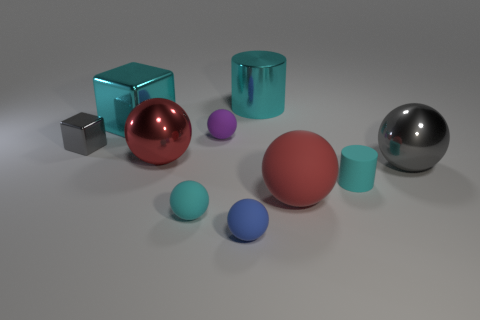Subtract all rubber balls. How many balls are left? 2 Subtract all cyan blocks. How many blocks are left? 1 Subtract all cylinders. How many objects are left? 8 Subtract 1 cylinders. How many cylinders are left? 1 Subtract all green cubes. How many brown cylinders are left? 0 Subtract 0 purple blocks. How many objects are left? 10 Subtract all brown balls. Subtract all red cubes. How many balls are left? 6 Subtract all large rubber spheres. Subtract all big matte spheres. How many objects are left? 8 Add 7 big shiny spheres. How many big shiny spheres are left? 9 Add 10 large gray metal blocks. How many large gray metal blocks exist? 10 